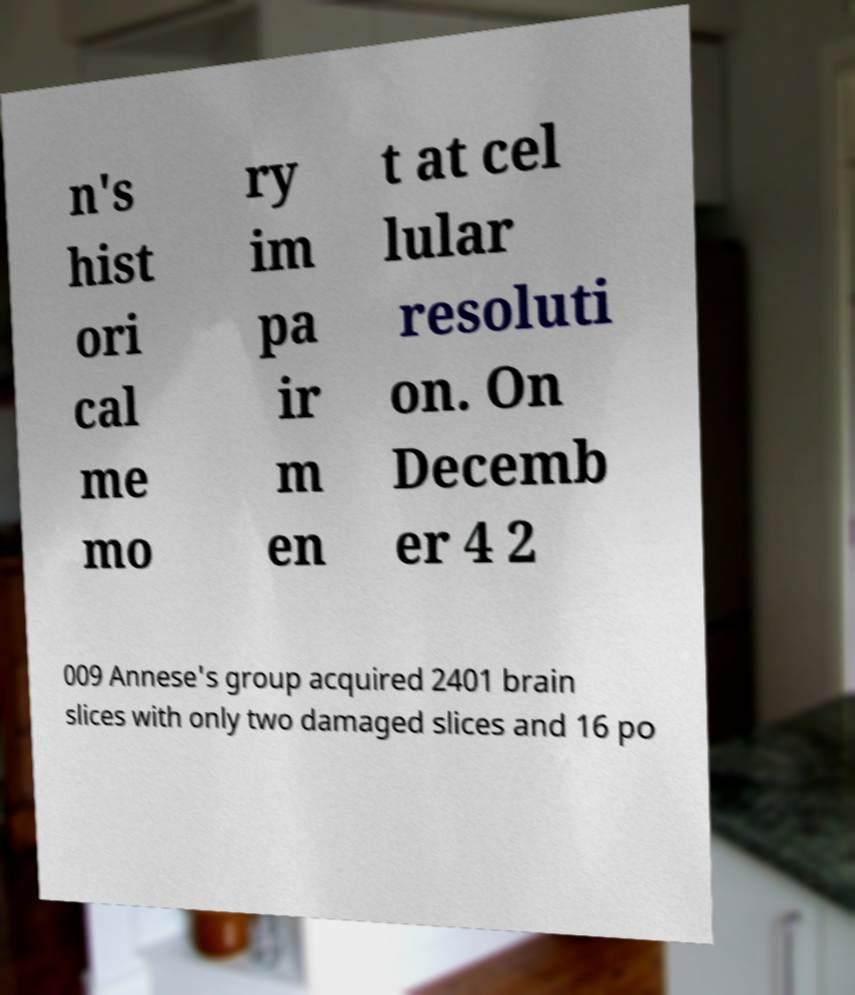I need the written content from this picture converted into text. Can you do that? n's hist ori cal me mo ry im pa ir m en t at cel lular resoluti on. On Decemb er 4 2 009 Annese's group acquired 2401 brain slices with only two damaged slices and 16 po 